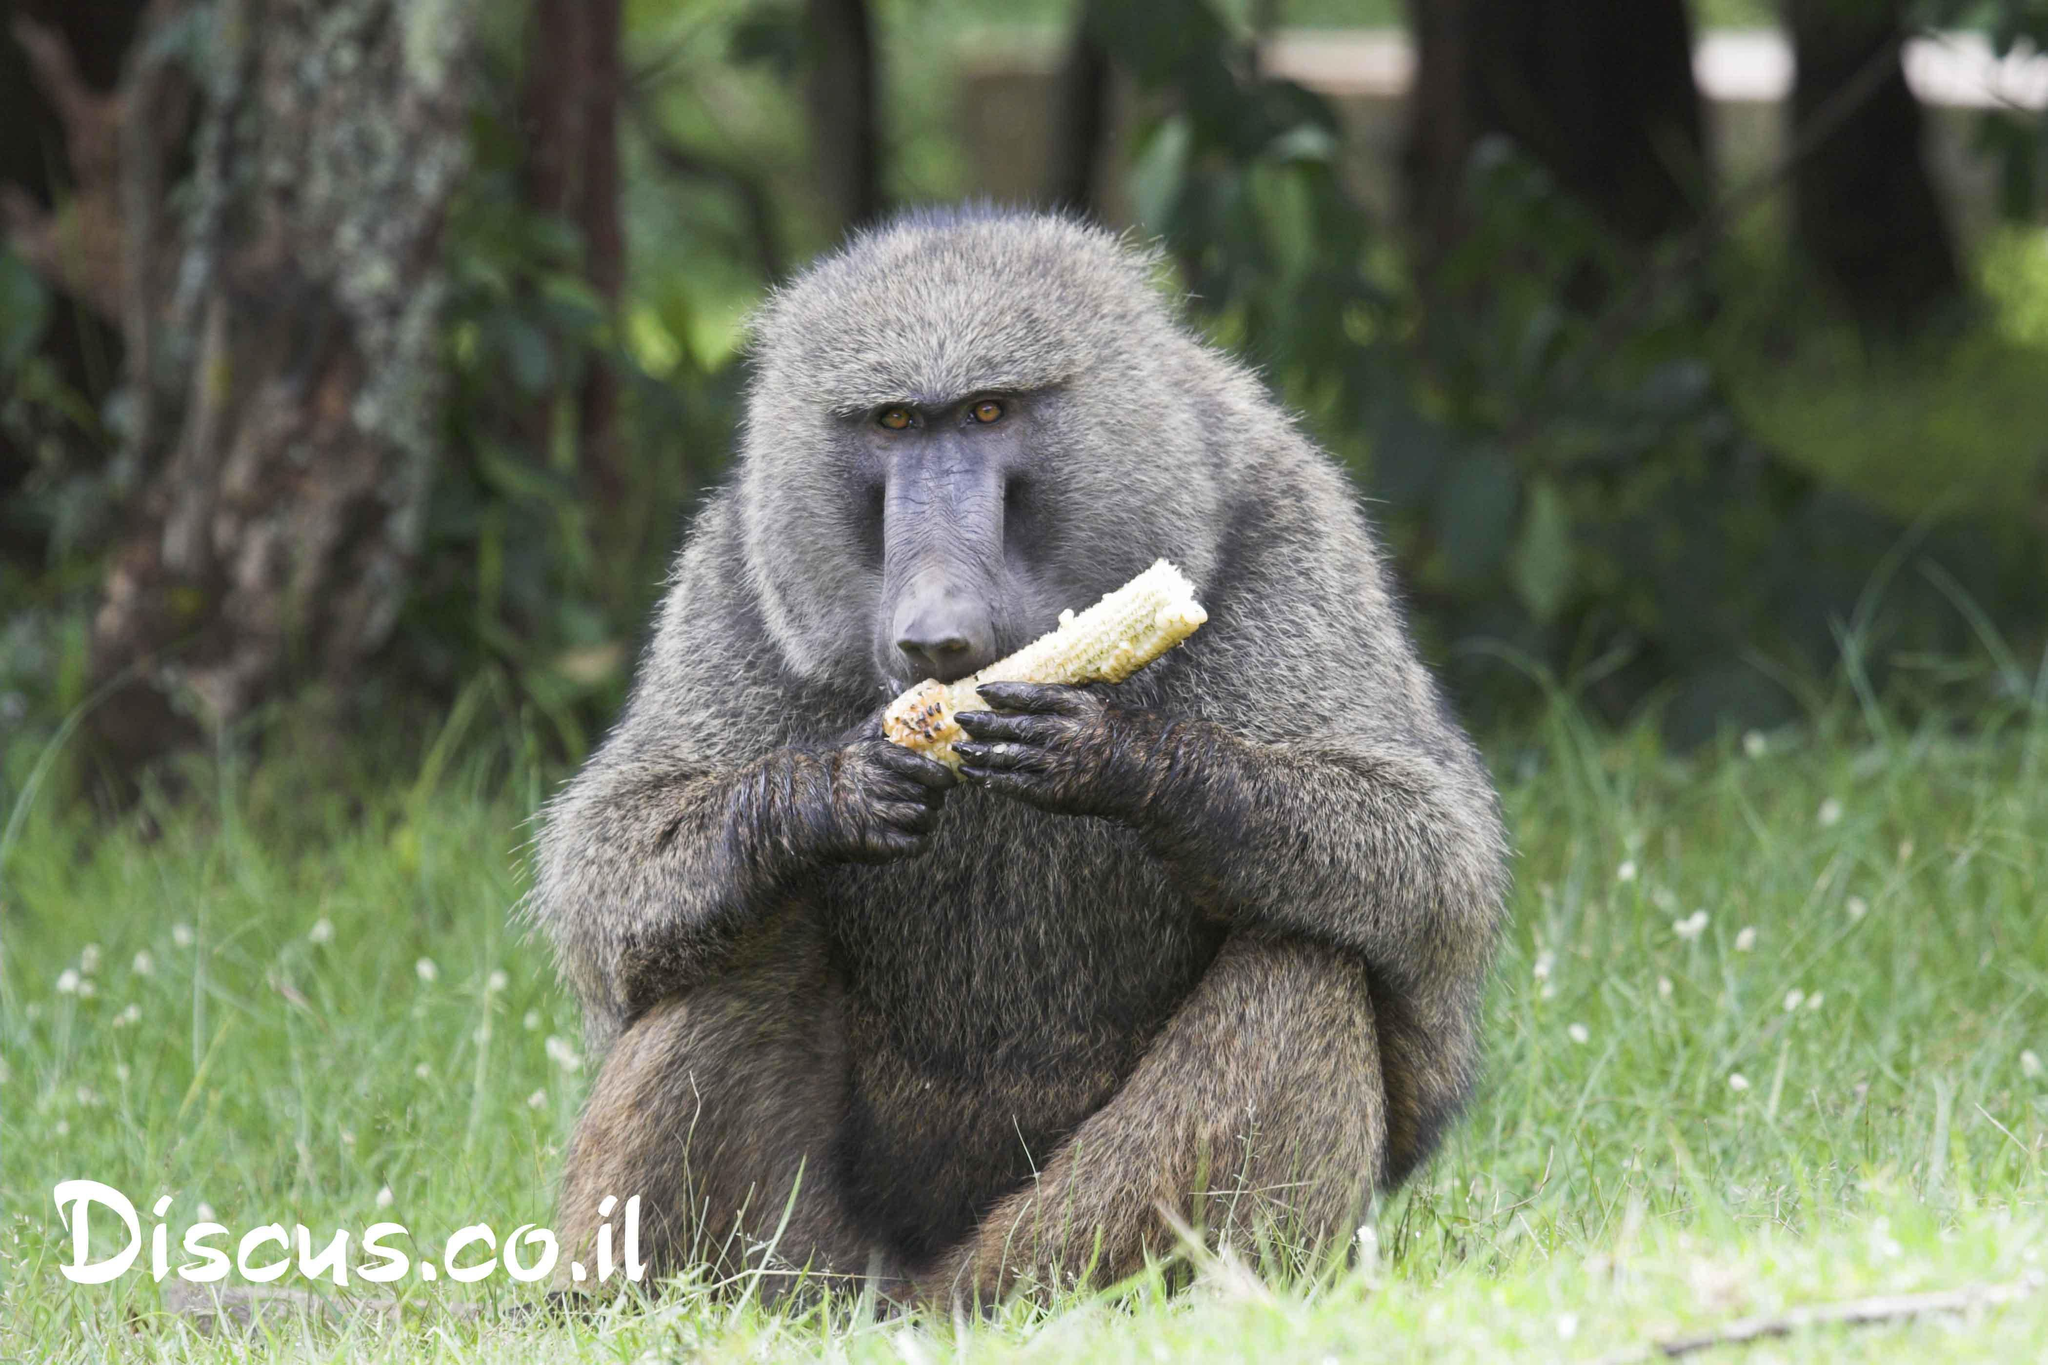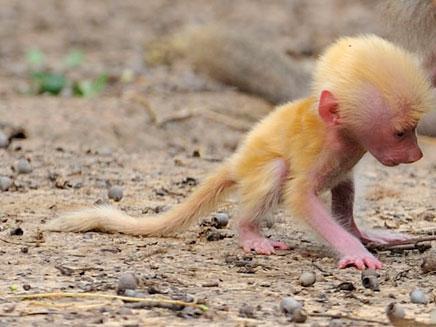The first image is the image on the left, the second image is the image on the right. Given the left and right images, does the statement "There is a body of water behind a monkey." hold true? Answer yes or no. No. 